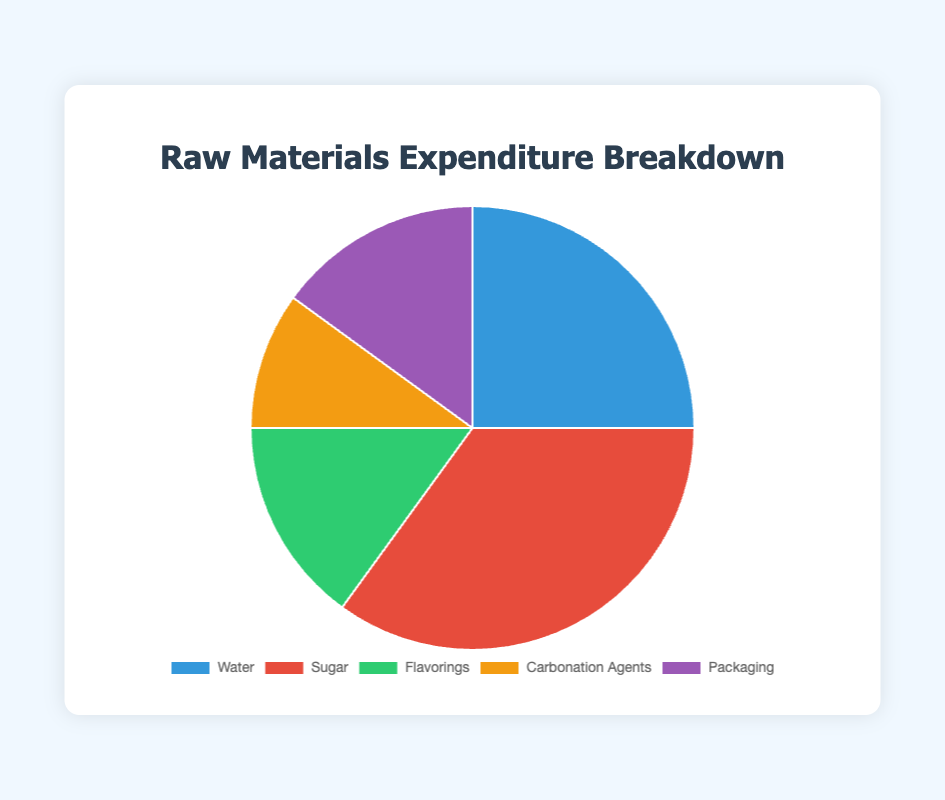What proportion of the total budget is spent on the combination of Flavorings and Packaging? The proportion of the budget spent on Flavorings is 15%, and for Packaging, it is also 15%. Adding these together, we get 15% + 15% = 30%.
Answer: 30% Which raw material category has the highest expenditure? The categories and their proportions are as follows: Water (25%), Sugar (35%), Flavorings (15%), Carbonation Agents (10%), and Packaging (15%). Sugar has the highest expenditure at 35%.
Answer: Sugar Is more budget spent on Carbonation Agents than on Flavorings? The expenditure on Carbonation Agents is 10%, while Flavorings have an expenditure of 15%. Since 10% is less than 15%, less budget is spent on Carbonation Agents.
Answer: No What is the combined expenditure on Water and Sugar? The expenditure on Water is 25%, and for Sugar, it is 35%. Adding these amounts gives us 25% + 35% = 60%.
Answer: 60% Which category has a greater expenditure: Packaging or Carbonation Agents? The expenditure on Packaging is 15%, whereas Carbonation Agents have an expenditure of 10%. Since 15% is greater than 10%, Packaging has a greater expenditure.
Answer: Packaging Among all raw materials, which has the smallest proportion of the budget spent on it? The proportions of the budget are: Water (25%), Sugar (35%), Flavorings (15%), Carbonation Agents (10%), and Packaging (15%). The smallest proportion is for Carbonation Agents at 10%.
Answer: Carbonation Agents How does the expenditure on Water compare to that of Flavorings and Carbonation Agents combined? The expenditure on Water is 25%. The combined expenditure on Flavorings (15%) and Carbonation Agents (10%) is 15% + 10% = 25%. Both have equal expenditures.
Answer: Equal What is the average expenditure per category across all raw materials? The total expenditure is the sum of all categories: 25% (Water) + 35% (Sugar) + 15% (Flavorings) + 10% (Carbonation Agents) + 15% (Packaging) = 100%. There are 5 categories, so the average expenditure per category is 100% / 5 = 20%.
Answer: 20% Which component occupies the green color in the pie chart? By color coding in the visual information, the green segment represents Flavorings.
Answer: Flavorings 